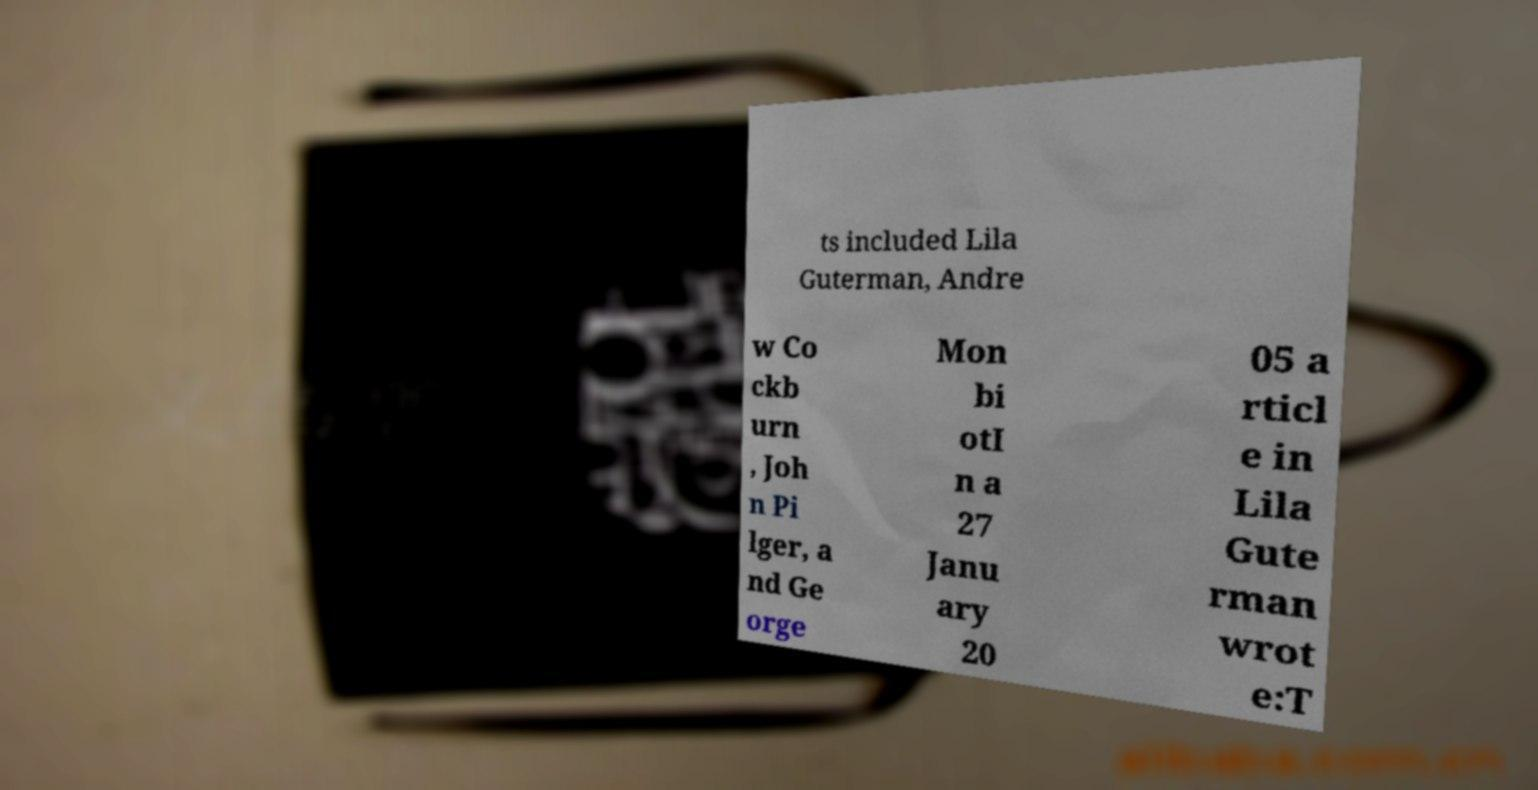For documentation purposes, I need the text within this image transcribed. Could you provide that? ts included Lila Guterman, Andre w Co ckb urn , Joh n Pi lger, a nd Ge orge Mon bi otI n a 27 Janu ary 20 05 a rticl e in Lila Gute rman wrot e:T 